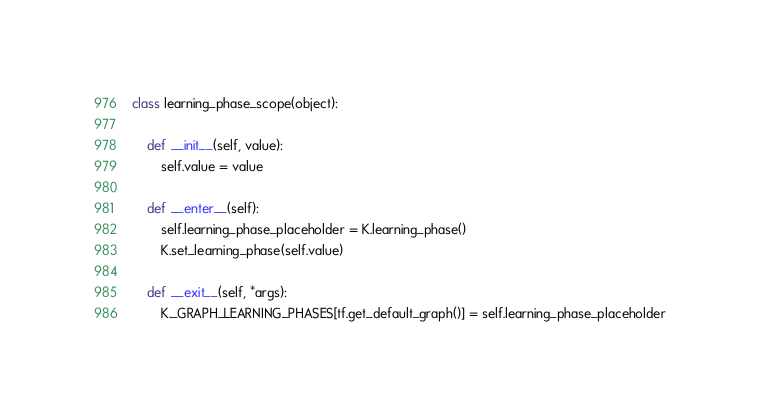<code> <loc_0><loc_0><loc_500><loc_500><_Python_>

class learning_phase_scope(object):

    def __init__(self, value):
        self.value = value

    def __enter__(self):
        self.learning_phase_placeholder = K.learning_phase()
        K.set_learning_phase(self.value)

    def __exit__(self, *args):
        K._GRAPH_LEARNING_PHASES[tf.get_default_graph()] = self.learning_phase_placeholder
</code> 